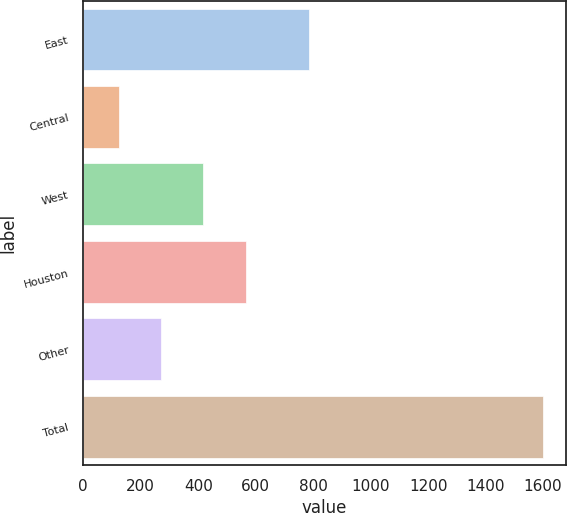Convert chart. <chart><loc_0><loc_0><loc_500><loc_500><bar_chart><fcel>East<fcel>Central<fcel>West<fcel>Houston<fcel>Other<fcel>Total<nl><fcel>787<fcel>123<fcel>418.2<fcel>565.8<fcel>270.6<fcel>1599<nl></chart> 